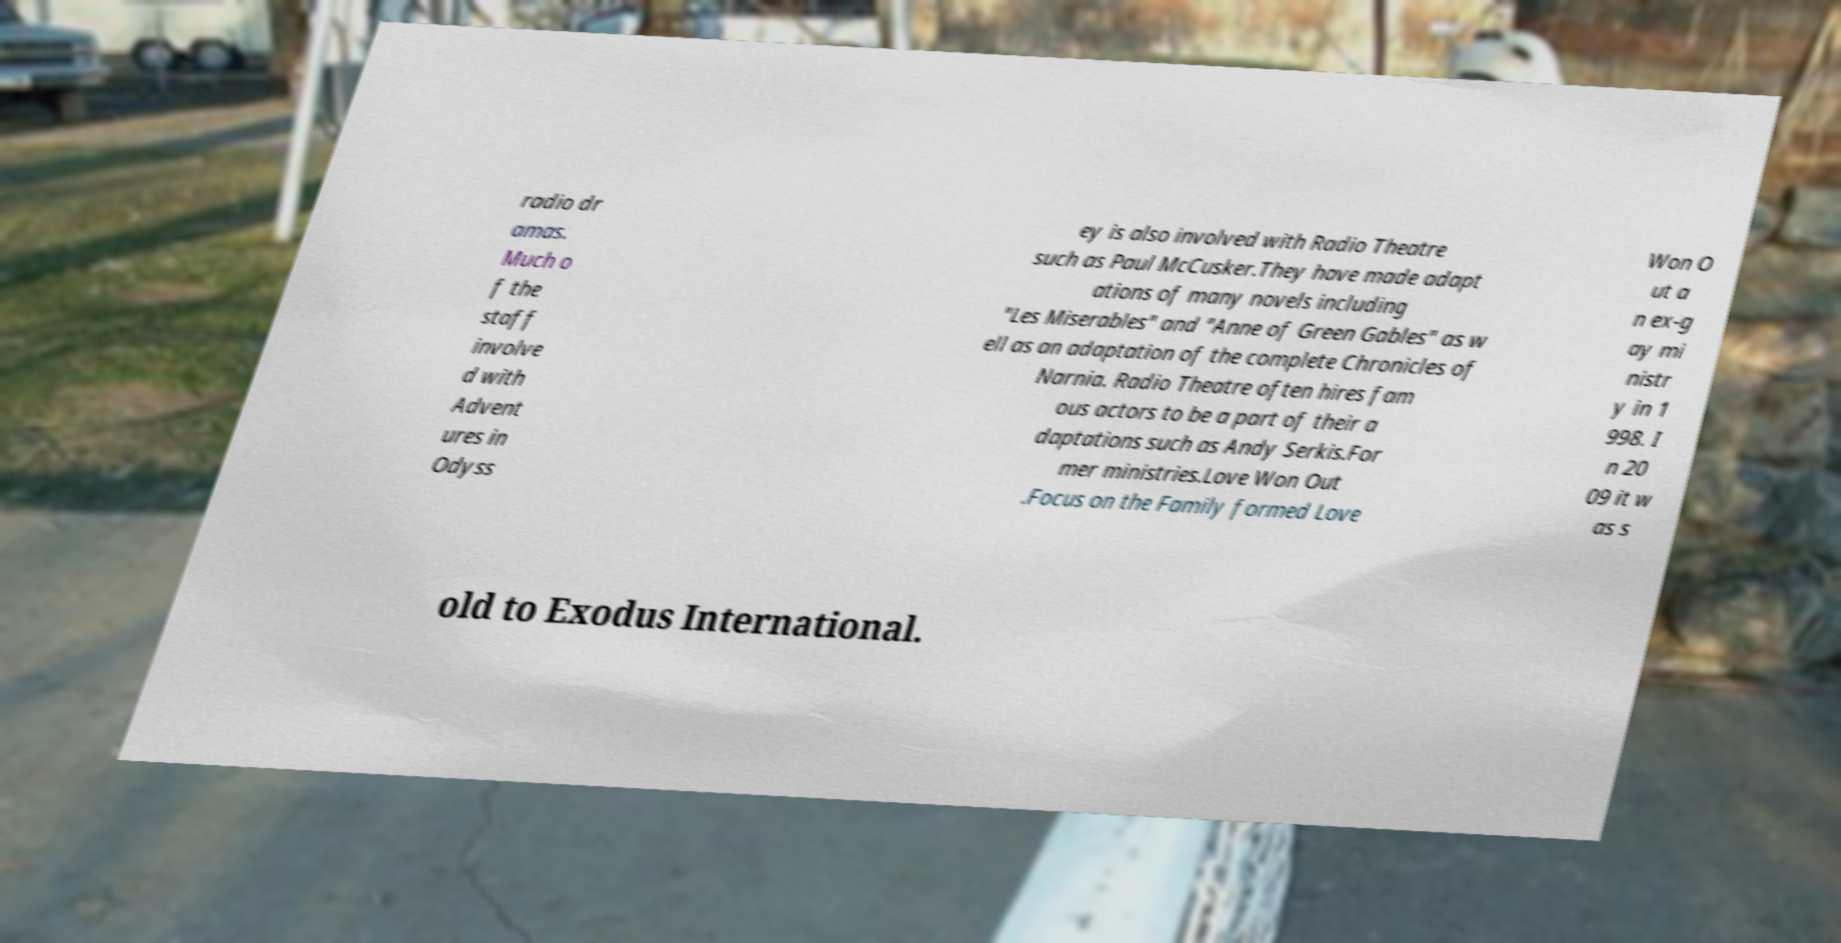What messages or text are displayed in this image? I need them in a readable, typed format. radio dr amas. Much o f the staff involve d with Advent ures in Odyss ey is also involved with Radio Theatre such as Paul McCusker.They have made adapt ations of many novels including "Les Miserables" and "Anne of Green Gables" as w ell as an adaptation of the complete Chronicles of Narnia. Radio Theatre often hires fam ous actors to be a part of their a daptations such as Andy Serkis.For mer ministries.Love Won Out .Focus on the Family formed Love Won O ut a n ex-g ay mi nistr y in 1 998. I n 20 09 it w as s old to Exodus International. 